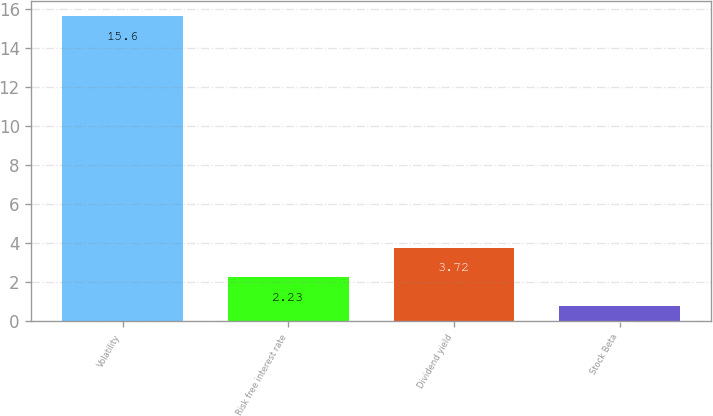<chart> <loc_0><loc_0><loc_500><loc_500><bar_chart><fcel>Volatility<fcel>Risk free interest rate<fcel>Dividend yield<fcel>Stock Beta<nl><fcel>15.6<fcel>2.23<fcel>3.72<fcel>0.74<nl></chart> 